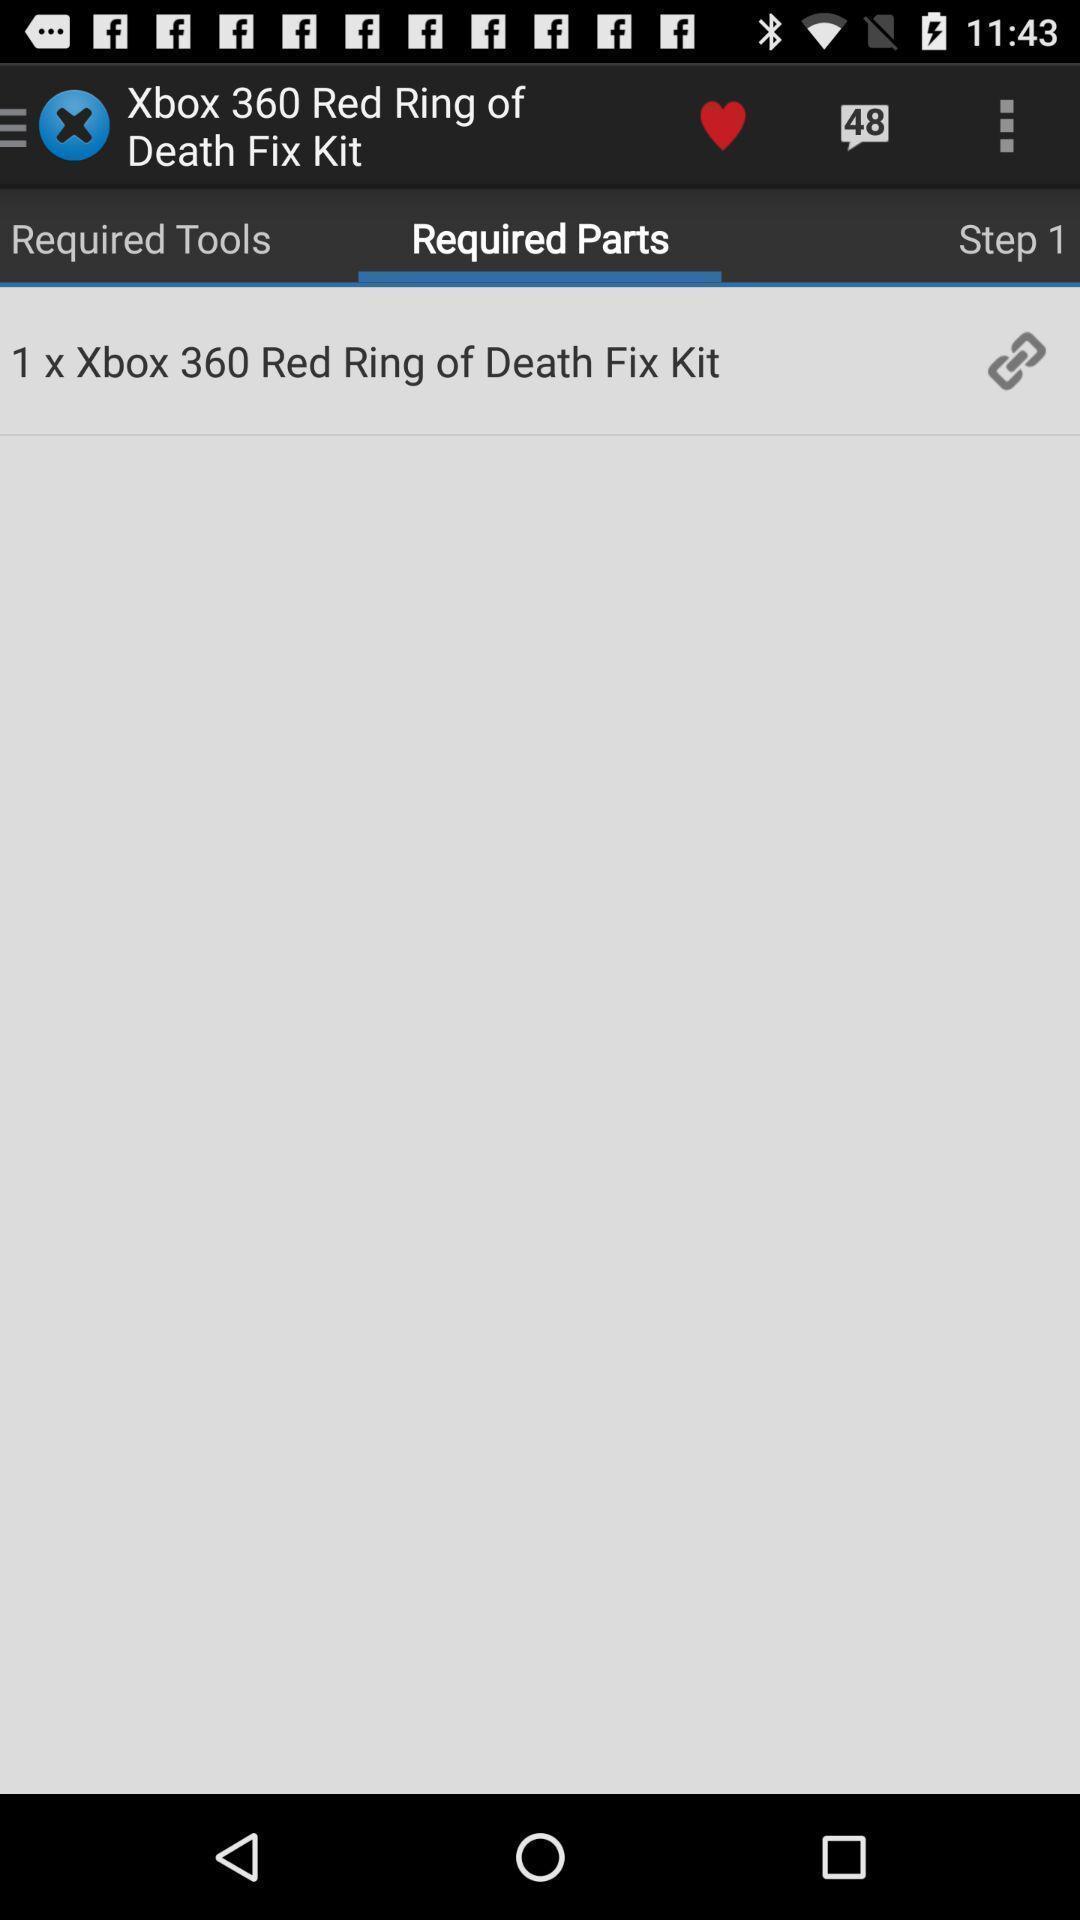Describe the visual elements of this screenshot. Page displaying required parts. 